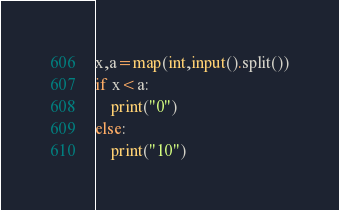Convert code to text. <code><loc_0><loc_0><loc_500><loc_500><_Python_>x,a=map(int,input().split())
if x<a:
	print("0")
else:
	print("10")</code> 